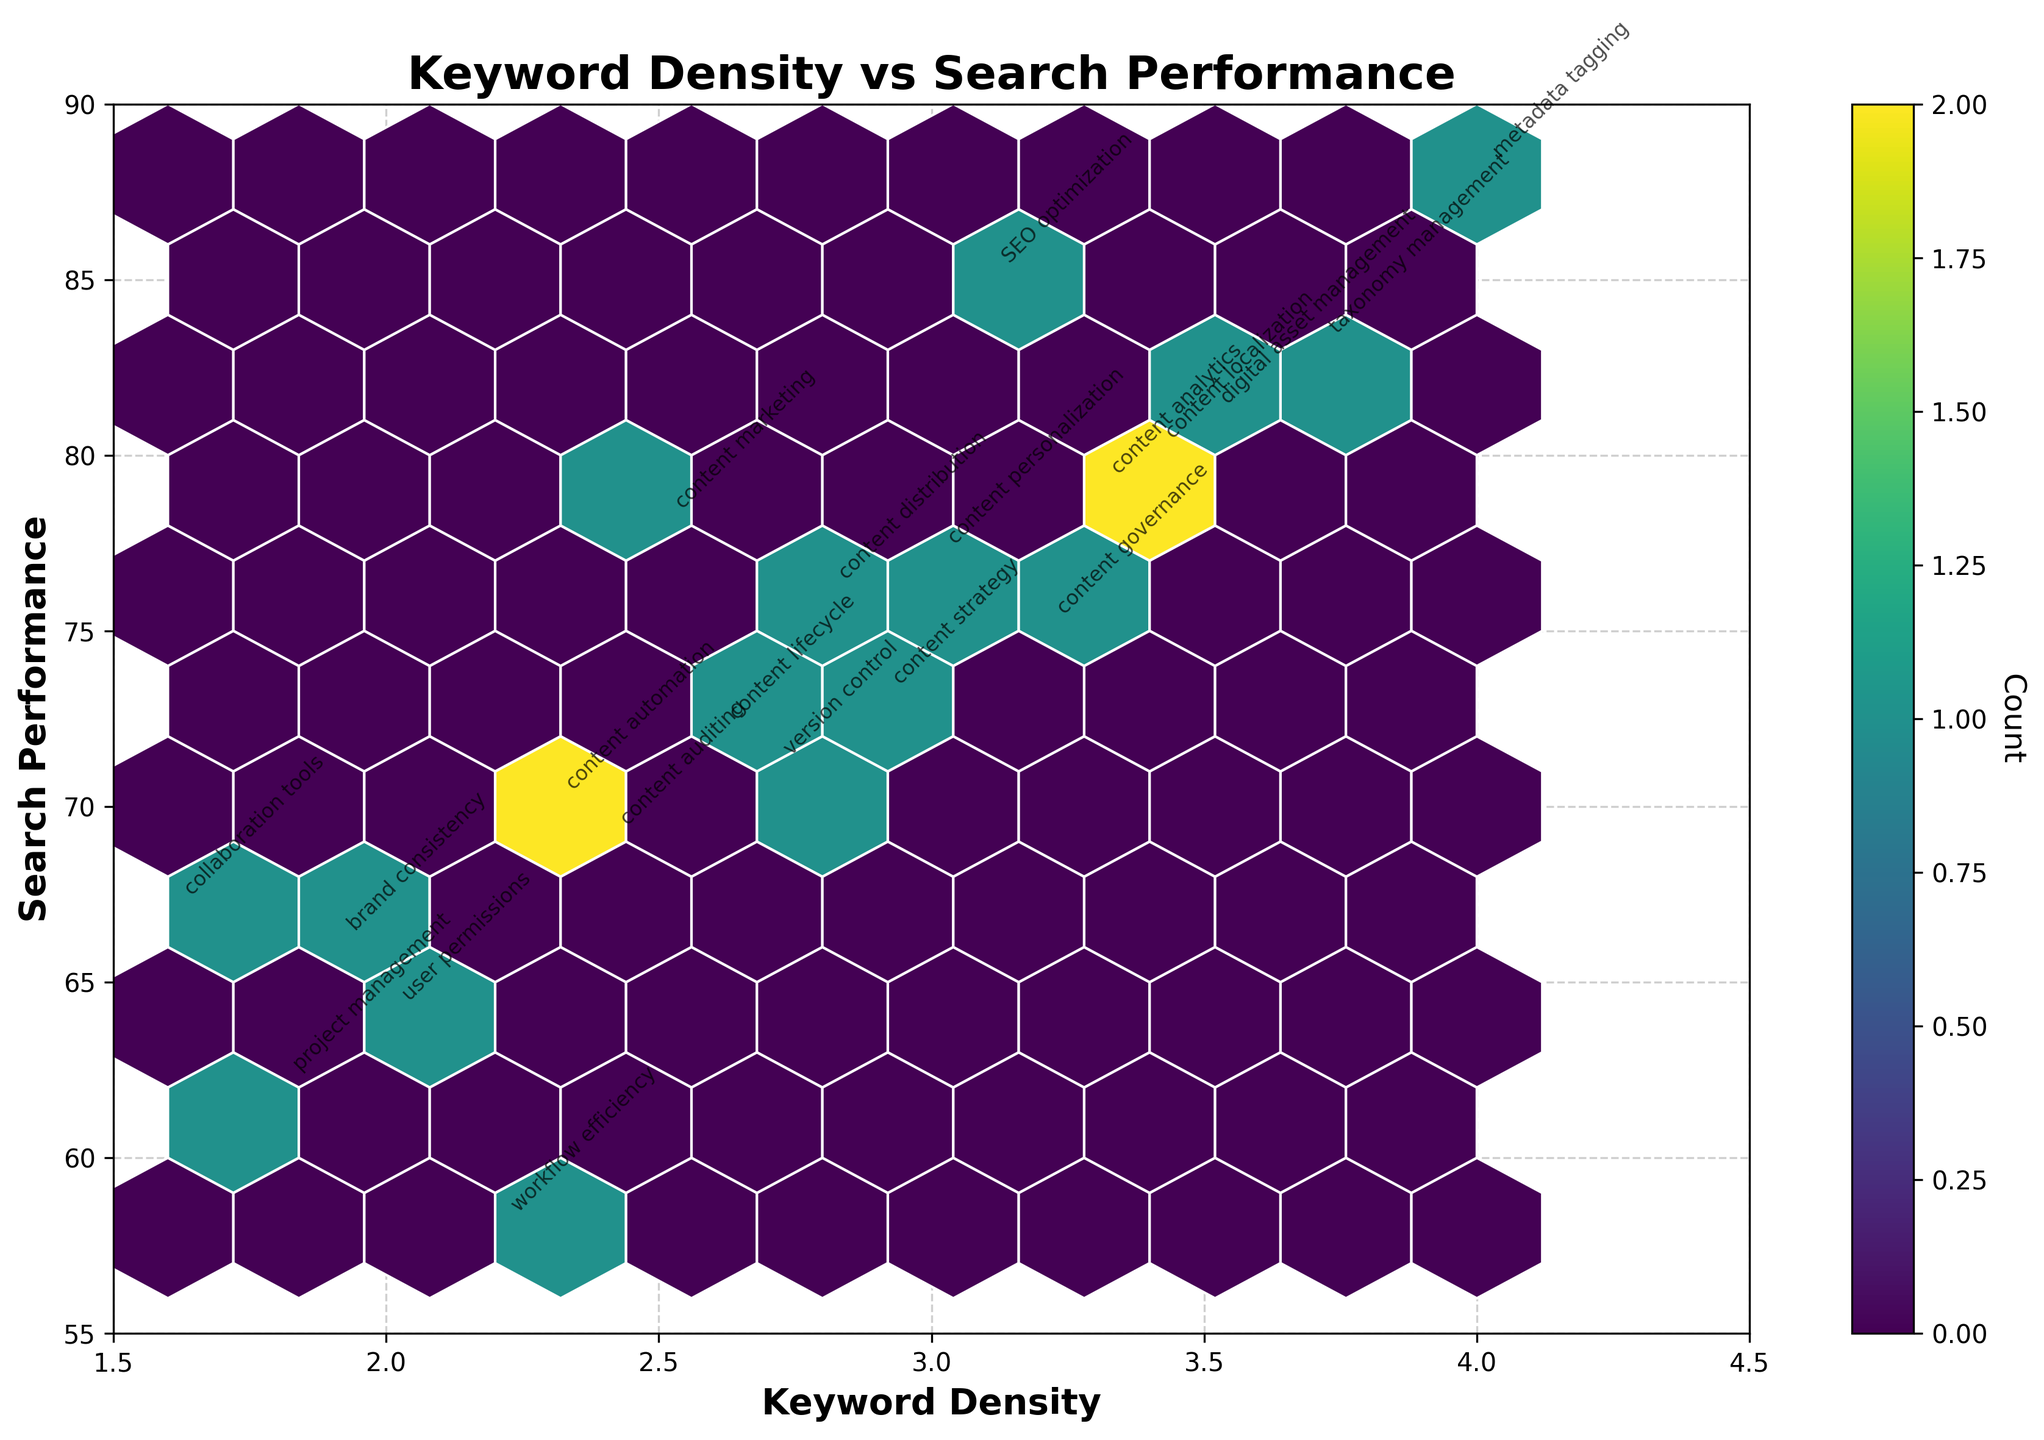What's the title of the figure? The title is displayed at the top of the figure and describes the content of the plot. In this case, the title is "Keyword Density vs Search Performance", which indicates that the plot shows the relationship between keyword density and search performance metrics.
Answer: Keyword Density vs Search Performance What are the labels for the x and y axes? The labels for the axes signify what each axis represents. Here, the x-axis is labeled "Keyword Density" and the y-axis is labeled "Search Performance", indicating the variables being plotted.
Answer: Keyword Density; Search Performance How many data points are shown in the plot? Each keyword is a data point in the plot. The number of keywords listed in the provided data is 20.
Answer: 20 Which color represents higher counts in the hexbin plot? The color bar indicates the count, with the color palette ranging from light to dark. In this plot, darker colors (closer to the color 'viridis') represent higher counts.
Answer: Darker colors Which keyword has the highest search performance and what is its density? To find this, look for the keyword with the highest value on the y-axis. "metadata tagging" has the highest search performance at 88, with a keyword density of 4.0.
Answer: metadata tagging; 4.0 What is the keyword density range in the plot? The range of the x-axis, labeled "Keyword Density", sets the minimum and maximum values plotted. Here, it ranges from 1.5 to 4.5.
Answer: 1.5 to 4.5 Calculate the average search performance for keywords with a density greater than 3. We need to find the keywords with density > 3, sum their search performance, and divide by their count. Keywords are "SEO optimization" (85), "digital asset management" (81), "metadata tagging" (88), "taxonomy management" (83), "content governance" (75), "content localization" (80). Their average is (85 + 81 + 88 + 83 + 75 + 80) / 6 = 82
Answer: 82 Which keywords are positioned in the densest hexagon? The densest hexagon will be in the darkest color. We then check the plot to see which keywords fall into this hexagon, needing reference from the hex plot and annotated keywords. This requires visual analysis of the plot color and point placement.
Answer: Needs visualization Is there a correlation between keyword density and search performance? To determine correlation, observe the overall trend in the plot. If denser keyword values tend to have higher or lower performance consistently, it may indicate correlation. Here, higher densities often show relatively high search performance, suggesting a positive correlation.
Answer: Positive correlation 